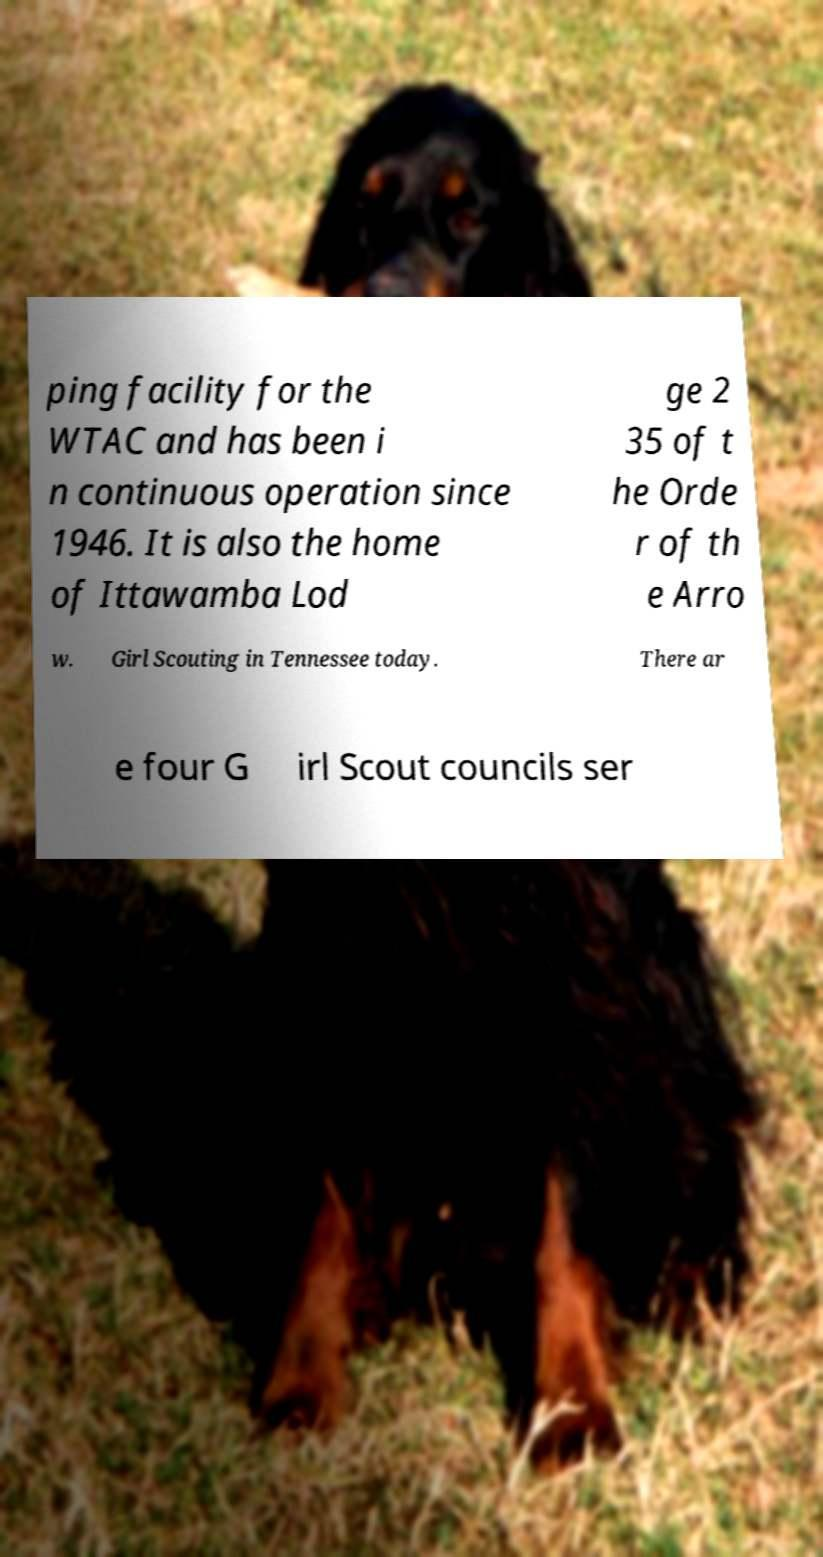Please identify and transcribe the text found in this image. ping facility for the WTAC and has been i n continuous operation since 1946. It is also the home of Ittawamba Lod ge 2 35 of t he Orde r of th e Arro w. Girl Scouting in Tennessee today. There ar e four G irl Scout councils ser 